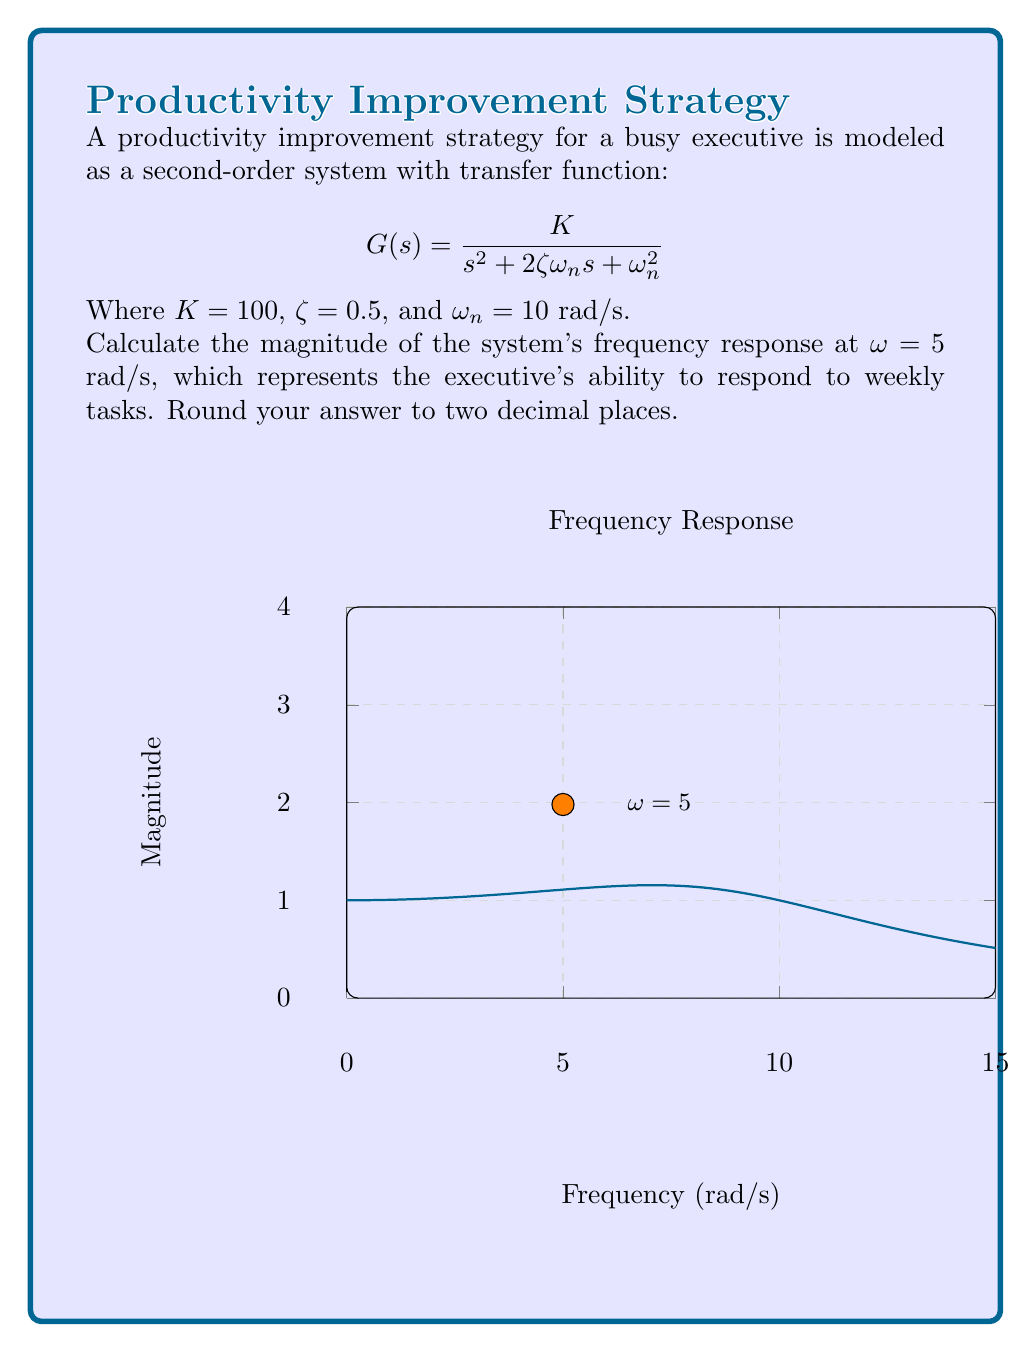What is the answer to this math problem? To find the magnitude of the frequency response, we follow these steps:

1) The frequency response is obtained by substituting $s$ with $j\omega$ in the transfer function:

   $$G(j\omega) = \frac{K}{(j\omega)^2 + 2\zeta\omega_n(j\omega) + \omega_n^2}$$

2) The magnitude is given by:

   $$|G(j\omega)| = \frac{K}{\sqrt{(\omega_n^2 - \omega^2)^2 + (2\zeta\omega_n\omega)^2}}$$

3) Substitute the given values: $K = 100$, $\zeta = 0.5$, $\omega_n = 10$ rad/s, and $\omega = 5$ rad/s:

   $$|G(j5)| = \frac{100}{\sqrt{(10^2 - 5^2)^2 + (2 \cdot 0.5 \cdot 10 \cdot 5)^2}}$$

4) Simplify:
   $$|G(j5)| = \frac{100}{\sqrt{(100 - 25)^2 + (50)^2}}$$
   $$|G(j5)| = \frac{100}{\sqrt{75^2 + 50^2}}$$
   $$|G(j5)| = \frac{100}{\sqrt{5625 + 2500}}$$
   $$|G(j5)| = \frac{100}{\sqrt{8125}}$$
   $$|G(j5)| = \frac{100}{90.14}$$
   $$|G(j5)| \approx 1.11$$

5) Rounding to two decimal places: 1.11
Answer: 1.11 